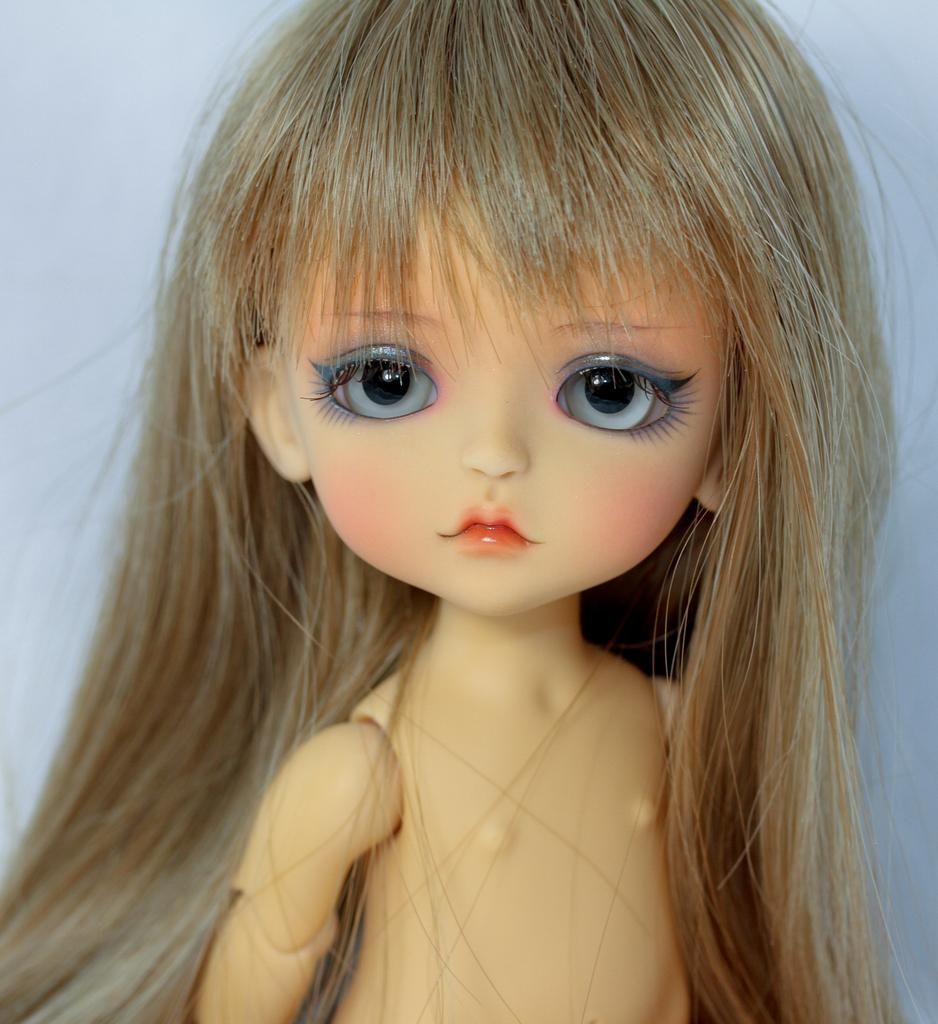What is the main subject of the image? The main subject of the image is a doll. What type of blood vessels can be seen in the doll's body in the image? There are no blood vessels visible in the image, as it features a doll and dolls do not have a biological circulatory system. 